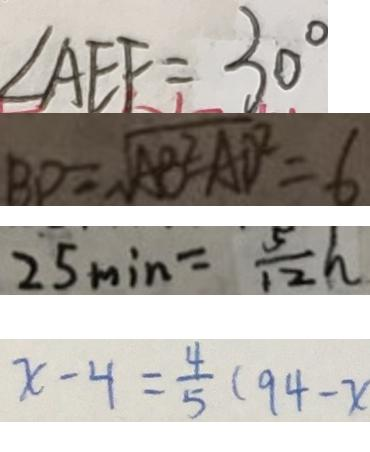Convert formula to latex. <formula><loc_0><loc_0><loc_500><loc_500>\angle A E F = 3 0 ^ { \circ } 
 B D = \sqrt { A B ^ { 2 } - A D ^ { 2 } } = 6 
 2 5 \min = \frac { 5 } { 1 2 } h 
 x - 4 = \frac { 4 } { 5 } ( 9 4 - x )</formula> 